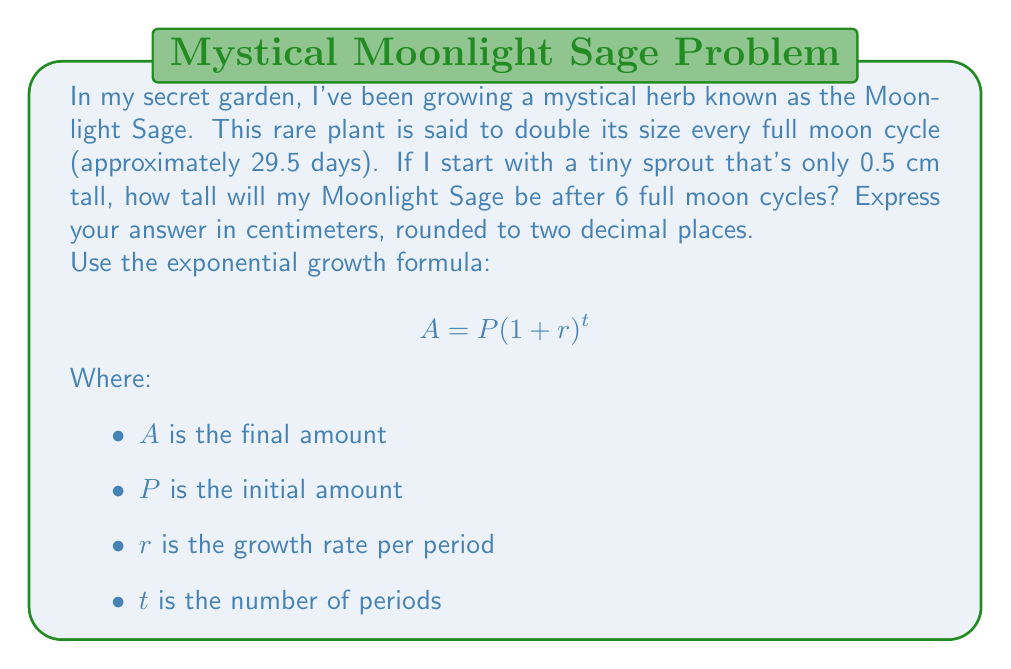Can you solve this math problem? To solve this problem, we'll use the exponential growth formula:

$$ A = P(1 + r)^t $$

Let's identify our variables:
$P = 0.5$ cm (initial height)
$r = 1$ (100% growth rate, as it doubles each cycle)
$t = 6$ (number of full moon cycles)

Now, let's substitute these values into our formula:

$$ A = 0.5(1 + 1)^6 $$

Simplify inside the parentheses:

$$ A = 0.5(2)^6 $$

Calculate the exponent:

$$ A = 0.5 \cdot 64 $$

Multiply:

$$ A = 32 \text{ cm} $$

Therefore, after 6 full moon cycles, the Moonlight Sage will be 32 cm tall.
Answer: 32.00 cm 